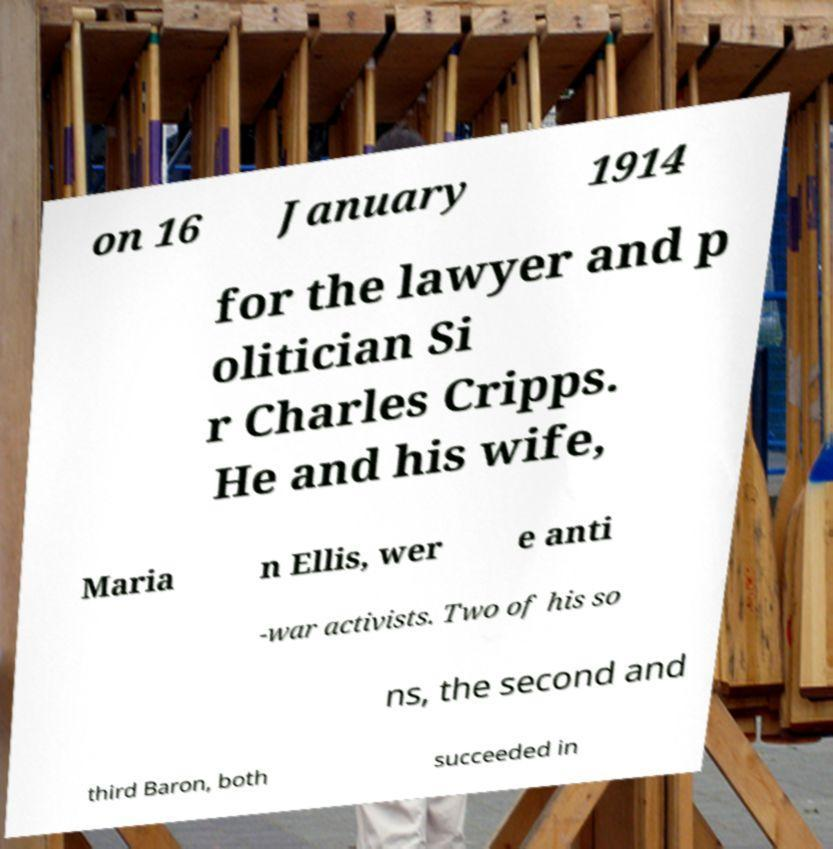Can you accurately transcribe the text from the provided image for me? on 16 January 1914 for the lawyer and p olitician Si r Charles Cripps. He and his wife, Maria n Ellis, wer e anti -war activists. Two of his so ns, the second and third Baron, both succeeded in 